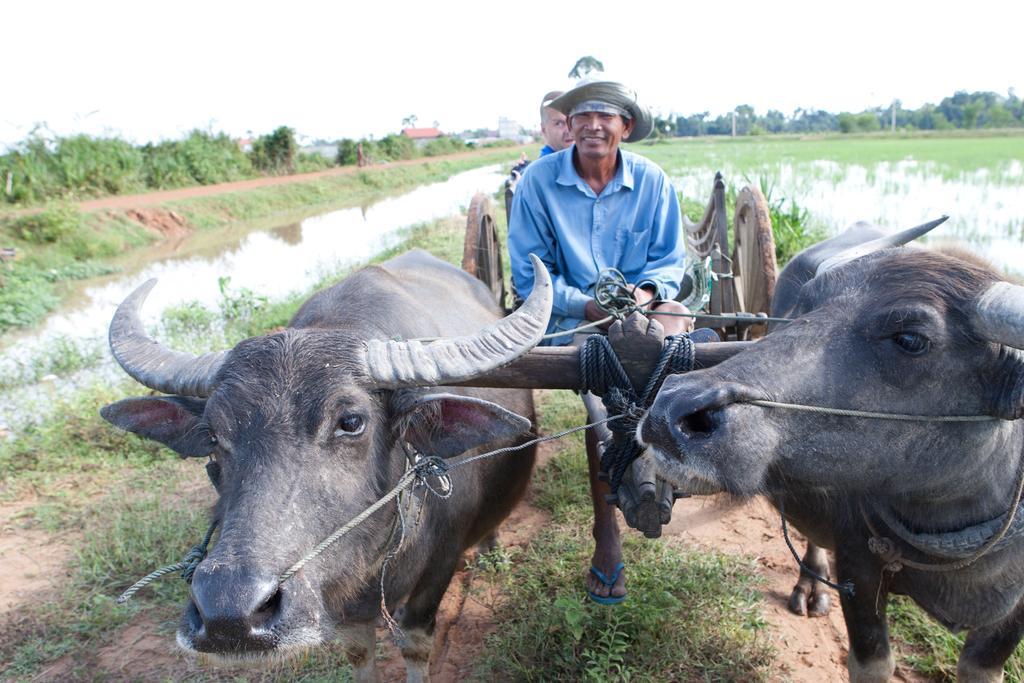Can you describe this image briefly? In this picture we can see two animals and two men, they are sitting in the cart, in the background we can see water few trees and poles. 